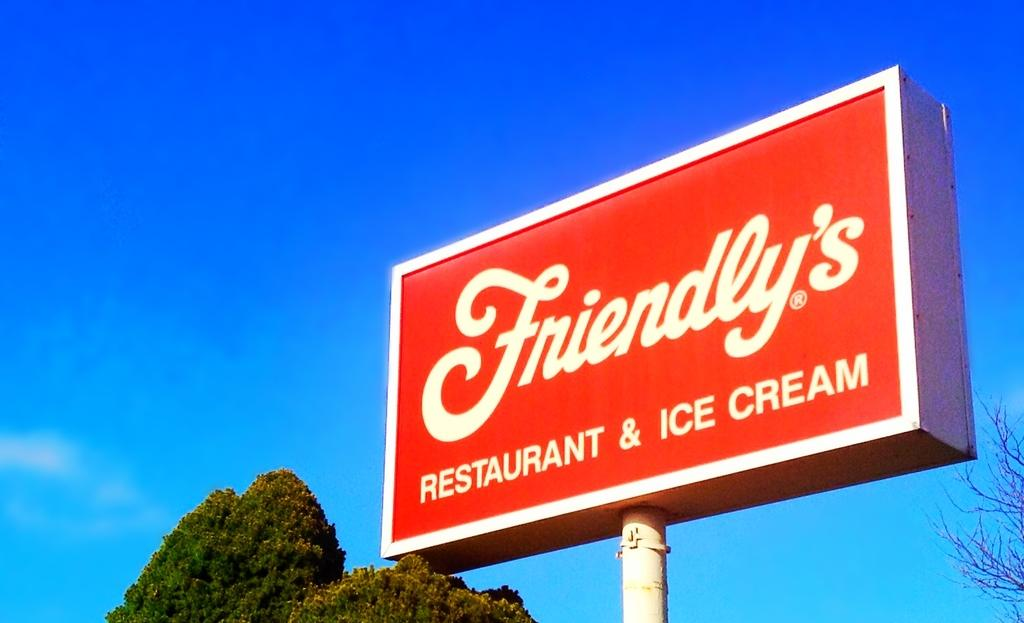<image>
Summarize the visual content of the image. a red sign with the name Friendly's on it outside 